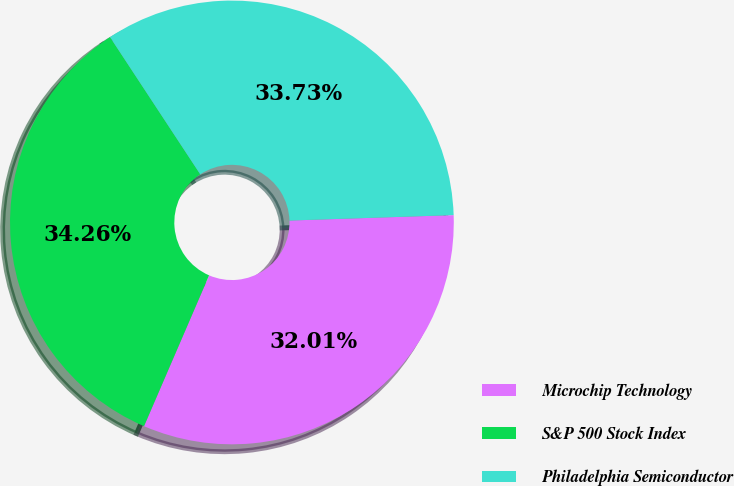Convert chart. <chart><loc_0><loc_0><loc_500><loc_500><pie_chart><fcel>Microchip Technology<fcel>S&P 500 Stock Index<fcel>Philadelphia Semiconductor<nl><fcel>32.01%<fcel>34.26%<fcel>33.73%<nl></chart> 